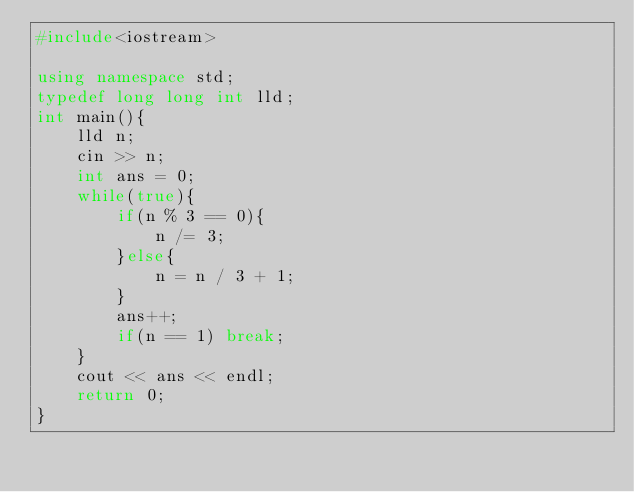Convert code to text. <code><loc_0><loc_0><loc_500><loc_500><_C++_>#include<iostream>

using namespace std;
typedef long long int lld;
int main(){
	lld n;
	cin >> n;
	int ans = 0;
	while(true){
		if(n % 3 == 0){
			n /= 3;
		}else{
			n = n / 3 + 1;
		}
		ans++;
		if(n == 1) break;
	}
	cout << ans << endl;
	return 0;
}
</code> 